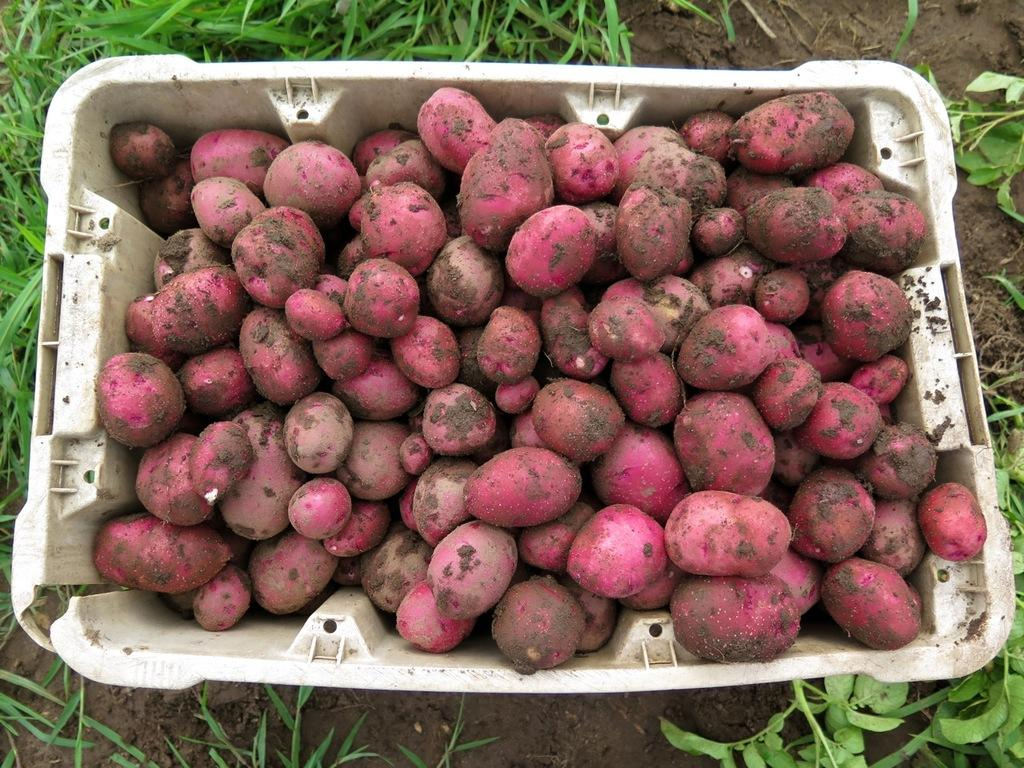What type of vegetation can be seen in the image? There is grass visible in the image. What object is present in the image that might be used for holding or containing items? There is a tub in the image. What is inside the tub in the image? There are vegetables in the tub. What type of secretary can be seen working in the image? There is no secretary present in the image; it features grass, a tub, and vegetables. What time of day is depicted in the image? The time of day is not mentioned or depicted in the image. 